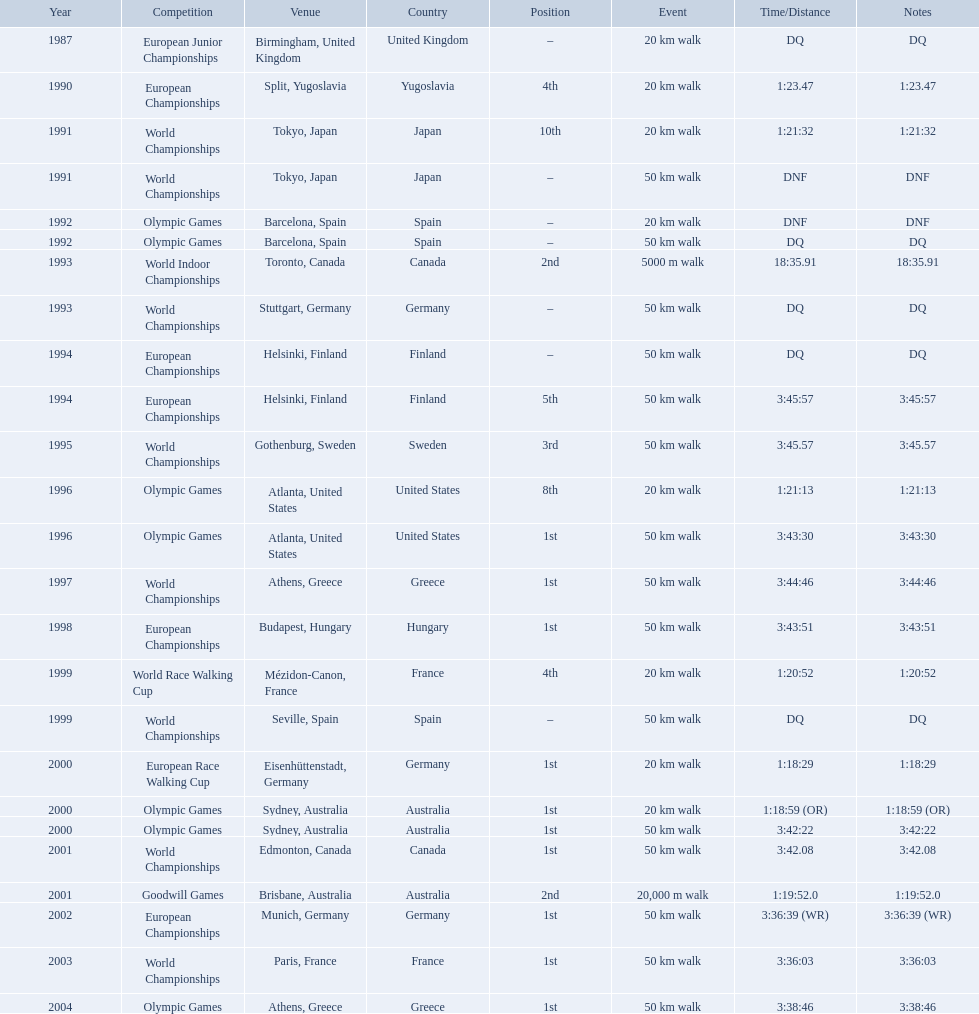In 1990 what position did robert korzeniowski place? 4th. In 1993 what was robert korzeniowski's place in the world indoor championships? 2nd. How long did the 50km walk in 2004 olympic cost? 3:38:46. 